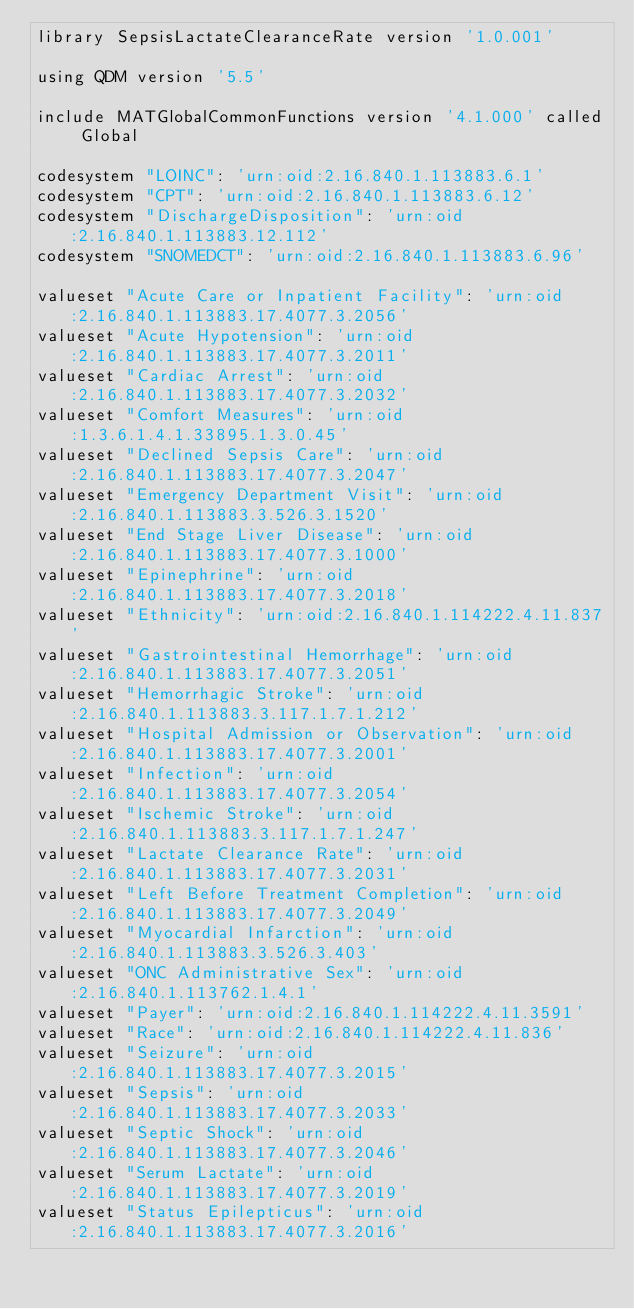Convert code to text. <code><loc_0><loc_0><loc_500><loc_500><_SQL_>library SepsisLactateClearanceRate version '1.0.001'

using QDM version '5.5'

include MATGlobalCommonFunctions version '4.1.000' called Global

codesystem "LOINC": 'urn:oid:2.16.840.1.113883.6.1'
codesystem "CPT": 'urn:oid:2.16.840.1.113883.6.12'
codesystem "DischargeDisposition": 'urn:oid:2.16.840.1.113883.12.112'
codesystem "SNOMEDCT": 'urn:oid:2.16.840.1.113883.6.96'

valueset "Acute Care or Inpatient Facility": 'urn:oid:2.16.840.1.113883.17.4077.3.2056'
valueset "Acute Hypotension": 'urn:oid:2.16.840.1.113883.17.4077.3.2011'
valueset "Cardiac Arrest": 'urn:oid:2.16.840.1.113883.17.4077.3.2032'
valueset "Comfort Measures": 'urn:oid:1.3.6.1.4.1.33895.1.3.0.45'
valueset "Declined Sepsis Care": 'urn:oid:2.16.840.1.113883.17.4077.3.2047'
valueset "Emergency Department Visit": 'urn:oid:2.16.840.1.113883.3.526.3.1520'
valueset "End Stage Liver Disease": 'urn:oid:2.16.840.1.113883.17.4077.3.1000'
valueset "Epinephrine": 'urn:oid:2.16.840.1.113883.17.4077.3.2018'
valueset "Ethnicity": 'urn:oid:2.16.840.1.114222.4.11.837'
valueset "Gastrointestinal Hemorrhage": 'urn:oid:2.16.840.1.113883.17.4077.3.2051'
valueset "Hemorrhagic Stroke": 'urn:oid:2.16.840.1.113883.3.117.1.7.1.212'
valueset "Hospital Admission or Observation": 'urn:oid:2.16.840.1.113883.17.4077.3.2001'
valueset "Infection": 'urn:oid:2.16.840.1.113883.17.4077.3.2054'
valueset "Ischemic Stroke": 'urn:oid:2.16.840.1.113883.3.117.1.7.1.247'
valueset "Lactate Clearance Rate": 'urn:oid:2.16.840.1.113883.17.4077.3.2031'
valueset "Left Before Treatment Completion": 'urn:oid:2.16.840.1.113883.17.4077.3.2049'
valueset "Myocardial Infarction": 'urn:oid:2.16.840.1.113883.3.526.3.403'
valueset "ONC Administrative Sex": 'urn:oid:2.16.840.1.113762.1.4.1'
valueset "Payer": 'urn:oid:2.16.840.1.114222.4.11.3591'
valueset "Race": 'urn:oid:2.16.840.1.114222.4.11.836'
valueset "Seizure": 'urn:oid:2.16.840.1.113883.17.4077.3.2015'
valueset "Sepsis": 'urn:oid:2.16.840.1.113883.17.4077.3.2033'
valueset "Septic Shock": 'urn:oid:2.16.840.1.113883.17.4077.3.2046'
valueset "Serum Lactate": 'urn:oid:2.16.840.1.113883.17.4077.3.2019'
valueset "Status Epilepticus": 'urn:oid:2.16.840.1.113883.17.4077.3.2016'</code> 